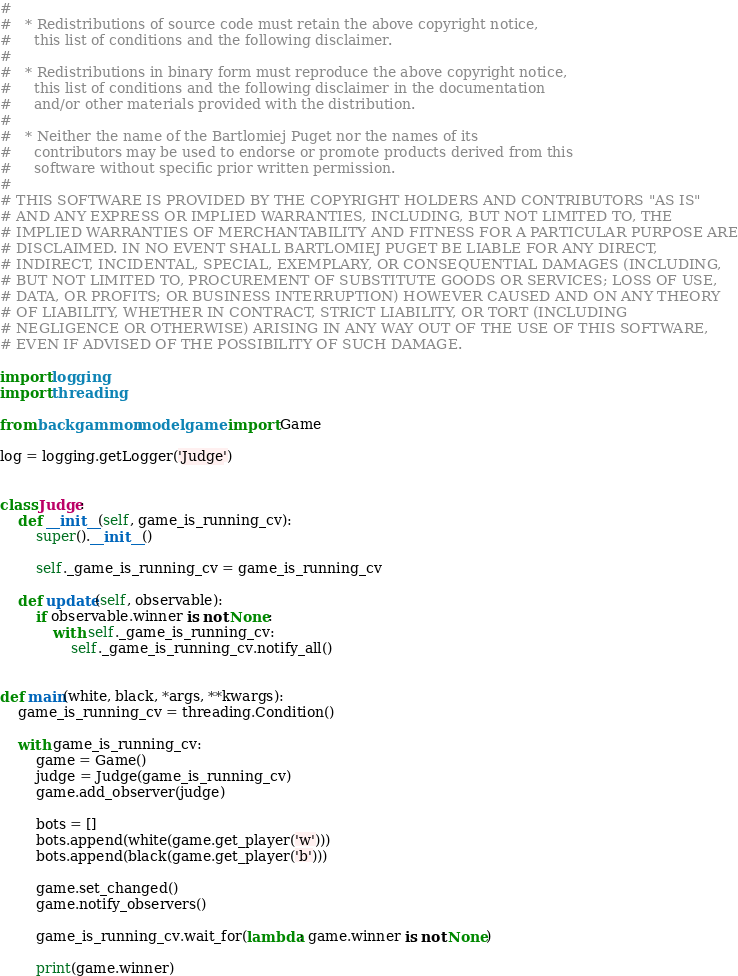<code> <loc_0><loc_0><loc_500><loc_500><_Python_>#
#   * Redistributions of source code must retain the above copyright notice,
#     this list of conditions and the following disclaimer.
#
#   * Redistributions in binary form must reproduce the above copyright notice,
#     this list of conditions and the following disclaimer in the documentation
#     and/or other materials provided with the distribution.
#
#   * Neither the name of the Bartlomiej Puget nor the names of its
#     contributors may be used to endorse or promote products derived from this
#     software without specific prior written permission.
#
# THIS SOFTWARE IS PROVIDED BY THE COPYRIGHT HOLDERS AND CONTRIBUTORS "AS IS"
# AND ANY EXPRESS OR IMPLIED WARRANTIES, INCLUDING, BUT NOT LIMITED TO, THE
# IMPLIED WARRANTIES OF MERCHANTABILITY AND FITNESS FOR A PARTICULAR PURPOSE ARE
# DISCLAIMED. IN NO EVENT SHALL BARTLOMIEJ PUGET BE LIABLE FOR ANY DIRECT,
# INDIRECT, INCIDENTAL, SPECIAL, EXEMPLARY, OR CONSEQUENTIAL DAMAGES (INCLUDING,
# BUT NOT LIMITED TO, PROCUREMENT OF SUBSTITUTE GOODS OR SERVICES; LOSS OF USE,
# DATA, OR PROFITS; OR BUSINESS INTERRUPTION) HOWEVER CAUSED AND ON ANY THEORY
# OF LIABILITY, WHETHER IN CONTRACT, STRICT LIABILITY, OR TORT (INCLUDING
# NEGLIGENCE OR OTHERWISE) ARISING IN ANY WAY OUT OF THE USE OF THIS SOFTWARE,
# EVEN IF ADVISED OF THE POSSIBILITY OF SUCH DAMAGE.

import logging
import threading

from backgammon.model.game import Game

log = logging.getLogger('Judge')


class Judge:
    def __init__(self, game_is_running_cv):
        super().__init__()

        self._game_is_running_cv = game_is_running_cv

    def update(self, observable):
        if observable.winner is not None:
            with self._game_is_running_cv:
                self._game_is_running_cv.notify_all()


def main(white, black, *args, **kwargs):
    game_is_running_cv = threading.Condition()

    with game_is_running_cv:
        game = Game()
        judge = Judge(game_is_running_cv)
        game.add_observer(judge)

        bots = []
        bots.append(white(game.get_player('w')))
        bots.append(black(game.get_player('b')))

        game.set_changed()
        game.notify_observers()

        game_is_running_cv.wait_for(lambda: game.winner is not None)

        print(game.winner)
</code> 